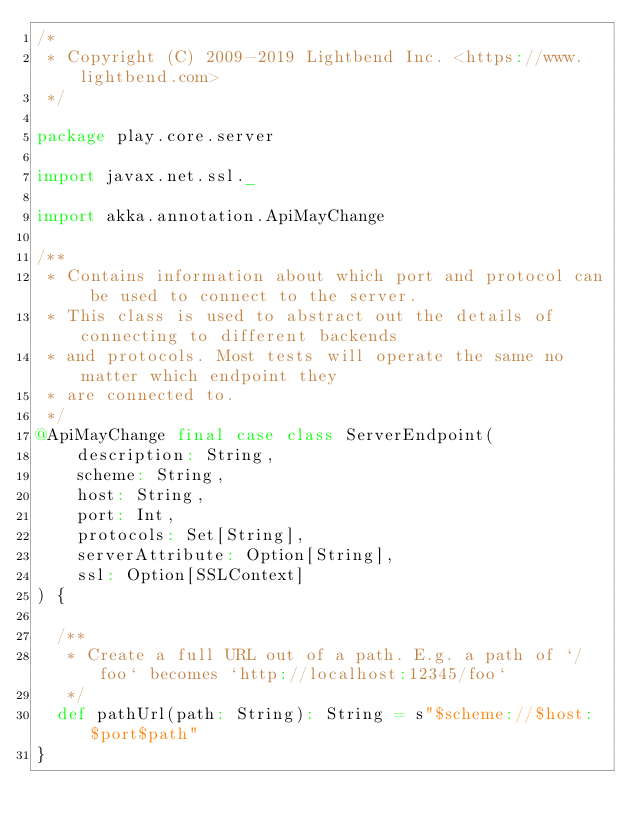<code> <loc_0><loc_0><loc_500><loc_500><_Scala_>/*
 * Copyright (C) 2009-2019 Lightbend Inc. <https://www.lightbend.com>
 */

package play.core.server

import javax.net.ssl._

import akka.annotation.ApiMayChange

/**
 * Contains information about which port and protocol can be used to connect to the server.
 * This class is used to abstract out the details of connecting to different backends
 * and protocols. Most tests will operate the same no matter which endpoint they
 * are connected to.
 */
@ApiMayChange final case class ServerEndpoint(
    description: String,
    scheme: String,
    host: String,
    port: Int,
    protocols: Set[String],
    serverAttribute: Option[String],
    ssl: Option[SSLContext]
) {

  /**
   * Create a full URL out of a path. E.g. a path of `/foo` becomes `http://localhost:12345/foo`
   */
  def pathUrl(path: String): String = s"$scheme://$host:$port$path"
}
</code> 